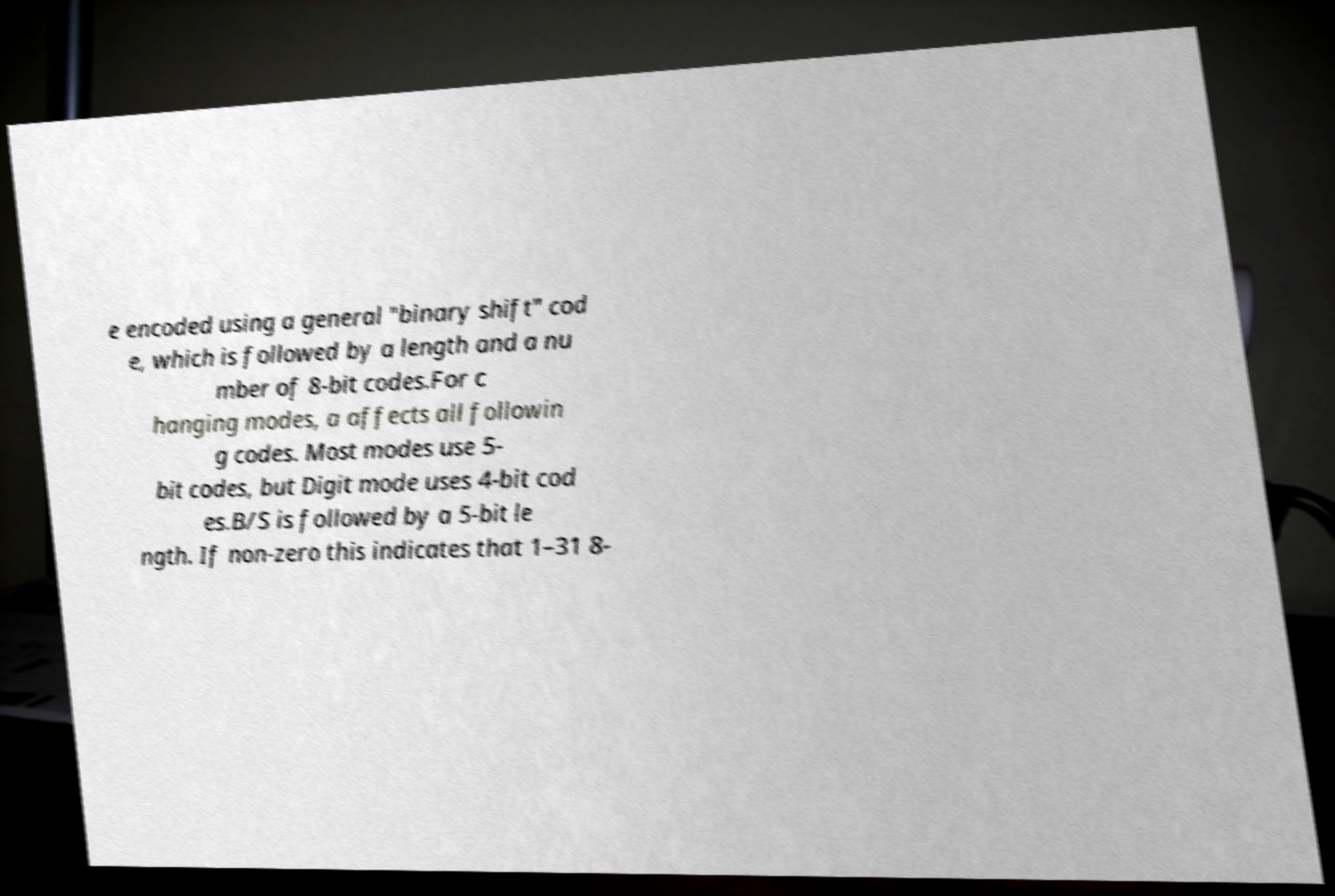For documentation purposes, I need the text within this image transcribed. Could you provide that? e encoded using a general "binary shift" cod e, which is followed by a length and a nu mber of 8-bit codes.For c hanging modes, a affects all followin g codes. Most modes use 5- bit codes, but Digit mode uses 4-bit cod es.B/S is followed by a 5-bit le ngth. If non-zero this indicates that 1–31 8- 